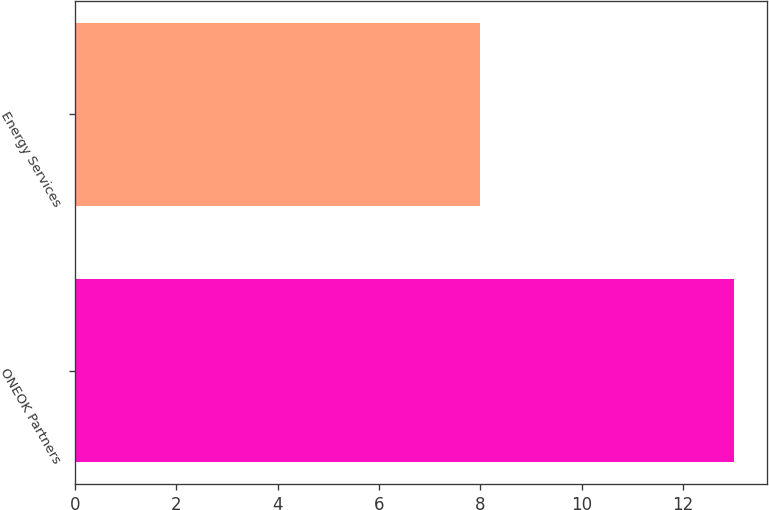Convert chart to OTSL. <chart><loc_0><loc_0><loc_500><loc_500><bar_chart><fcel>ONEOK Partners<fcel>Energy Services<nl><fcel>13<fcel>8<nl></chart> 